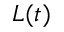<formula> <loc_0><loc_0><loc_500><loc_500>L ( t )</formula> 